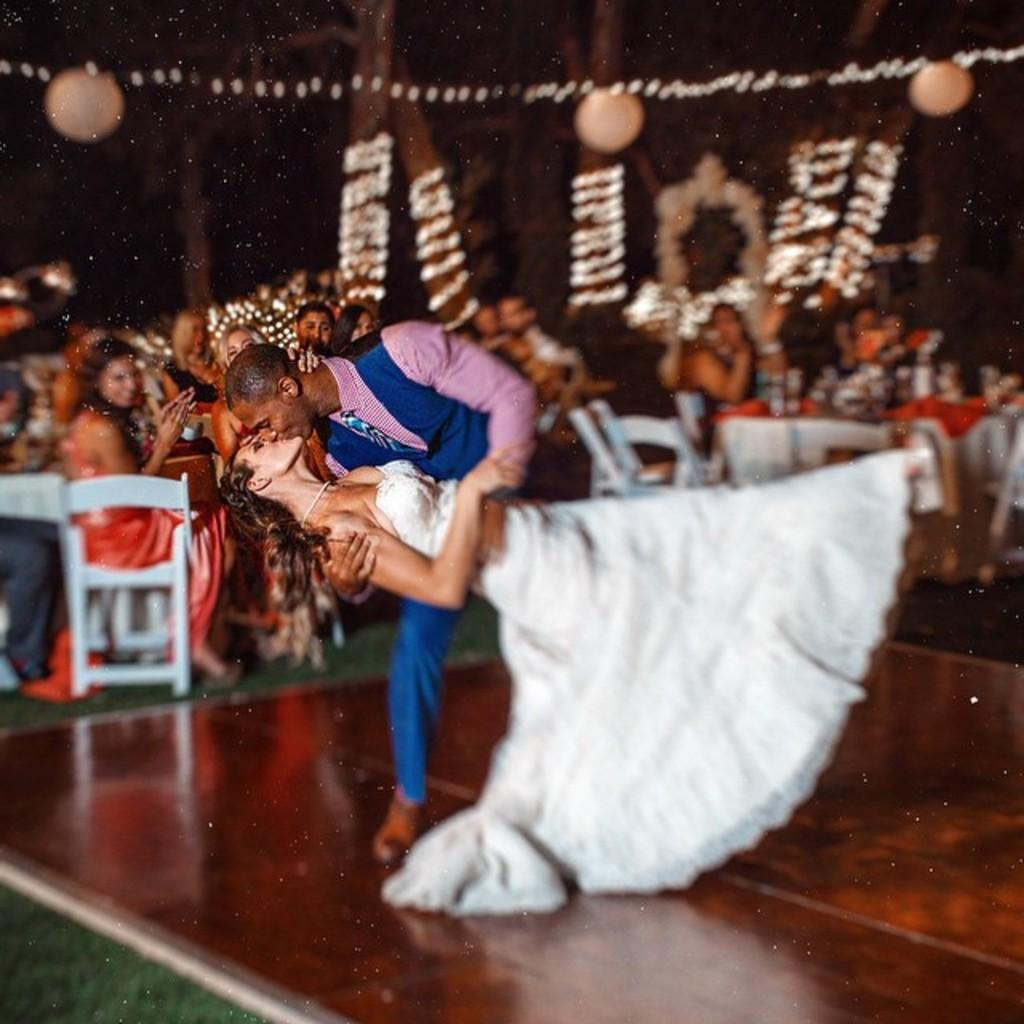What is happening between the person and the woman in the image? There is a person kissing a woman in the image. What can be seen in the background of the image? There are people sitting on chairs, tables, decorative balls, trees, and lights present in the background. How many people are sitting on chairs in the background? The number of people sitting on chairs is not specified in the facts, so it cannot be determined. What type of butter is being used by the farmer in the image? There is no farmer or butter present in the image. What is the person pointing at in the image? There is no indication of pointing in the image; the person is kissing the woman. 